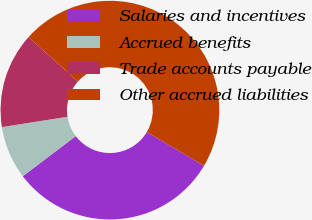<chart> <loc_0><loc_0><loc_500><loc_500><pie_chart><fcel>Salaries and incentives<fcel>Accrued benefits<fcel>Trade accounts payable<fcel>Other accrued liabilities<nl><fcel>31.17%<fcel>7.86%<fcel>14.1%<fcel>46.87%<nl></chart> 